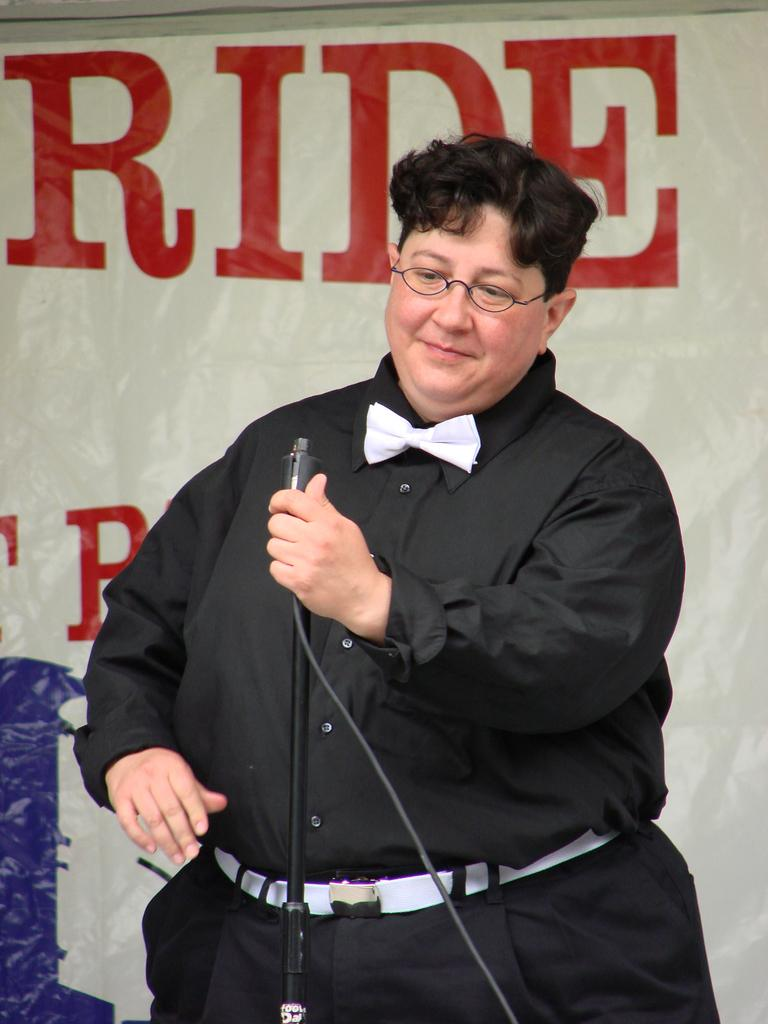Who is present in the image? There is a person in the image. What is the person doing in the image? The person is standing in front of a mic. Can you describe the person's appearance? The person is wearing spectacles. What can be seen in the background of the image? There is a banner in the background of the image. What is written on the banner? There is text on the banner. How many ladybugs are crawling on the person's spectacles in the image? There are no ladybugs present on the person's spectacles in the image. What type of beast can be seen roaring in the background of the image? There is no beast present in the image; only a person, a mic, and a banner are visible. 